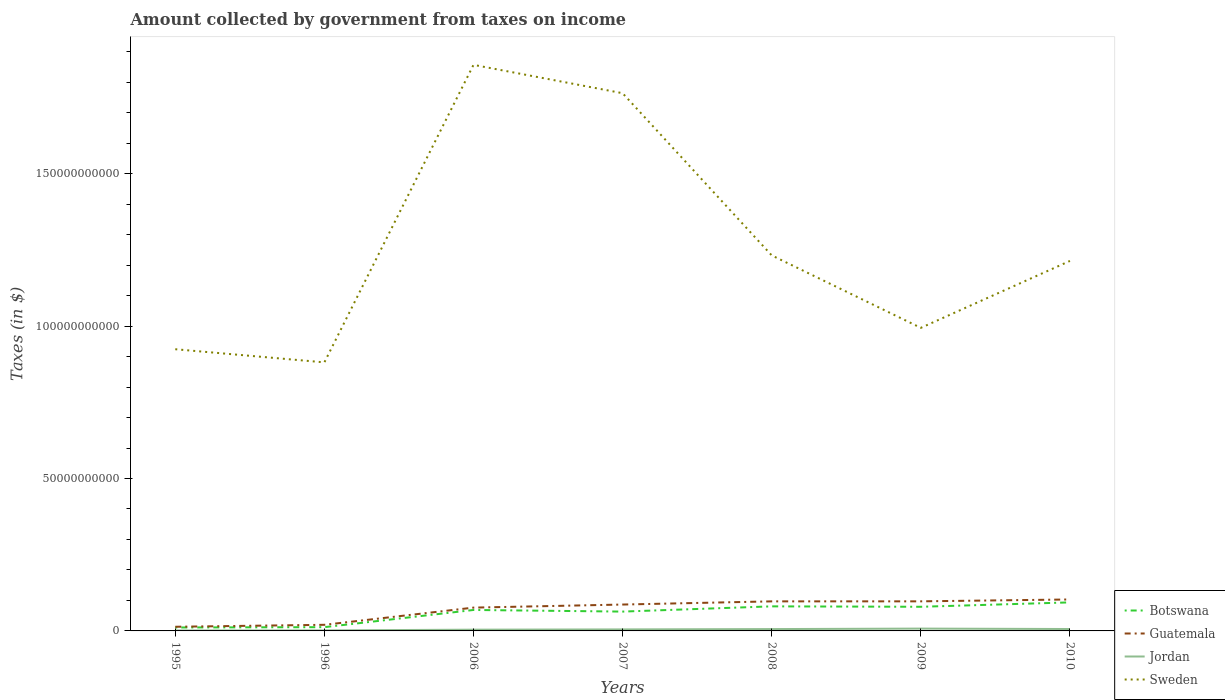How many different coloured lines are there?
Give a very brief answer. 4. Is the number of lines equal to the number of legend labels?
Your answer should be compact. Yes. Across all years, what is the maximum amount collected by government from taxes on income in Jordan?
Give a very brief answer. 1.52e+08. In which year was the amount collected by government from taxes on income in Botswana maximum?
Your response must be concise. 1995. What is the total amount collected by government from taxes on income in Jordan in the graph?
Ensure brevity in your answer.  1.40e+08. What is the difference between the highest and the second highest amount collected by government from taxes on income in Sweden?
Make the answer very short. 9.76e+1. How many lines are there?
Give a very brief answer. 4. Are the values on the major ticks of Y-axis written in scientific E-notation?
Your answer should be compact. No. Does the graph contain grids?
Your answer should be very brief. No. How many legend labels are there?
Ensure brevity in your answer.  4. What is the title of the graph?
Give a very brief answer. Amount collected by government from taxes on income. What is the label or title of the X-axis?
Give a very brief answer. Years. What is the label or title of the Y-axis?
Provide a succinct answer. Taxes (in $). What is the Taxes (in $) in Botswana in 1995?
Ensure brevity in your answer.  1.13e+09. What is the Taxes (in $) in Guatemala in 1995?
Your answer should be very brief. 1.37e+09. What is the Taxes (in $) of Jordan in 1995?
Make the answer very short. 1.52e+08. What is the Taxes (in $) of Sweden in 1995?
Offer a very short reply. 9.24e+1. What is the Taxes (in $) of Botswana in 1996?
Your response must be concise. 1.23e+09. What is the Taxes (in $) in Guatemala in 1996?
Ensure brevity in your answer.  2.00e+09. What is the Taxes (in $) of Jordan in 1996?
Provide a succinct answer. 1.73e+08. What is the Taxes (in $) of Sweden in 1996?
Your response must be concise. 8.81e+1. What is the Taxes (in $) in Botswana in 2006?
Your response must be concise. 6.88e+09. What is the Taxes (in $) of Guatemala in 2006?
Give a very brief answer. 7.65e+09. What is the Taxes (in $) of Jordan in 2006?
Keep it short and to the point. 4.11e+08. What is the Taxes (in $) in Sweden in 2006?
Keep it short and to the point. 1.86e+11. What is the Taxes (in $) of Botswana in 2007?
Ensure brevity in your answer.  6.34e+09. What is the Taxes (in $) of Guatemala in 2007?
Make the answer very short. 8.65e+09. What is the Taxes (in $) in Jordan in 2007?
Offer a very short reply. 4.95e+08. What is the Taxes (in $) of Sweden in 2007?
Your response must be concise. 1.76e+11. What is the Taxes (in $) of Botswana in 2008?
Provide a short and direct response. 8.06e+09. What is the Taxes (in $) of Guatemala in 2008?
Provide a short and direct response. 9.70e+09. What is the Taxes (in $) in Jordan in 2008?
Offer a terse response. 6.03e+08. What is the Taxes (in $) in Sweden in 2008?
Give a very brief answer. 1.23e+11. What is the Taxes (in $) in Botswana in 2009?
Keep it short and to the point. 7.92e+09. What is the Taxes (in $) in Guatemala in 2009?
Offer a terse response. 9.71e+09. What is the Taxes (in $) in Jordan in 2009?
Make the answer very short. 7.65e+08. What is the Taxes (in $) in Sweden in 2009?
Your answer should be compact. 9.94e+1. What is the Taxes (in $) in Botswana in 2010?
Provide a succinct answer. 9.36e+09. What is the Taxes (in $) of Guatemala in 2010?
Offer a terse response. 1.03e+1. What is the Taxes (in $) in Jordan in 2010?
Provide a short and direct response. 6.25e+08. What is the Taxes (in $) of Sweden in 2010?
Your answer should be compact. 1.21e+11. Across all years, what is the maximum Taxes (in $) of Botswana?
Your answer should be very brief. 9.36e+09. Across all years, what is the maximum Taxes (in $) in Guatemala?
Provide a short and direct response. 1.03e+1. Across all years, what is the maximum Taxes (in $) of Jordan?
Keep it short and to the point. 7.65e+08. Across all years, what is the maximum Taxes (in $) of Sweden?
Provide a short and direct response. 1.86e+11. Across all years, what is the minimum Taxes (in $) of Botswana?
Your answer should be compact. 1.13e+09. Across all years, what is the minimum Taxes (in $) in Guatemala?
Your response must be concise. 1.37e+09. Across all years, what is the minimum Taxes (in $) in Jordan?
Your answer should be compact. 1.52e+08. Across all years, what is the minimum Taxes (in $) in Sweden?
Offer a very short reply. 8.81e+1. What is the total Taxes (in $) in Botswana in the graph?
Your response must be concise. 4.09e+1. What is the total Taxes (in $) in Guatemala in the graph?
Provide a short and direct response. 4.94e+1. What is the total Taxes (in $) in Jordan in the graph?
Your answer should be very brief. 3.22e+09. What is the total Taxes (in $) of Sweden in the graph?
Make the answer very short. 8.87e+11. What is the difference between the Taxes (in $) of Botswana in 1995 and that in 1996?
Keep it short and to the point. -1.07e+08. What is the difference between the Taxes (in $) in Guatemala in 1995 and that in 1996?
Ensure brevity in your answer.  -6.39e+08. What is the difference between the Taxes (in $) of Jordan in 1995 and that in 1996?
Give a very brief answer. -2.06e+07. What is the difference between the Taxes (in $) in Sweden in 1995 and that in 1996?
Keep it short and to the point. 4.31e+09. What is the difference between the Taxes (in $) of Botswana in 1995 and that in 2006?
Ensure brevity in your answer.  -5.75e+09. What is the difference between the Taxes (in $) of Guatemala in 1995 and that in 2006?
Provide a short and direct response. -6.28e+09. What is the difference between the Taxes (in $) in Jordan in 1995 and that in 2006?
Your response must be concise. -2.59e+08. What is the difference between the Taxes (in $) of Sweden in 1995 and that in 2006?
Keep it short and to the point. -9.33e+1. What is the difference between the Taxes (in $) of Botswana in 1995 and that in 2007?
Your answer should be compact. -5.22e+09. What is the difference between the Taxes (in $) in Guatemala in 1995 and that in 2007?
Provide a succinct answer. -7.29e+09. What is the difference between the Taxes (in $) of Jordan in 1995 and that in 2007?
Keep it short and to the point. -3.42e+08. What is the difference between the Taxes (in $) of Sweden in 1995 and that in 2007?
Provide a short and direct response. -8.40e+1. What is the difference between the Taxes (in $) in Botswana in 1995 and that in 2008?
Offer a terse response. -6.93e+09. What is the difference between the Taxes (in $) in Guatemala in 1995 and that in 2008?
Offer a terse response. -8.33e+09. What is the difference between the Taxes (in $) in Jordan in 1995 and that in 2008?
Offer a very short reply. -4.51e+08. What is the difference between the Taxes (in $) of Sweden in 1995 and that in 2008?
Your answer should be very brief. -3.08e+1. What is the difference between the Taxes (in $) in Botswana in 1995 and that in 2009?
Ensure brevity in your answer.  -6.79e+09. What is the difference between the Taxes (in $) of Guatemala in 1995 and that in 2009?
Provide a short and direct response. -8.34e+09. What is the difference between the Taxes (in $) of Jordan in 1995 and that in 2009?
Keep it short and to the point. -6.12e+08. What is the difference between the Taxes (in $) of Sweden in 1995 and that in 2009?
Provide a succinct answer. -7.01e+09. What is the difference between the Taxes (in $) in Botswana in 1995 and that in 2010?
Ensure brevity in your answer.  -8.24e+09. What is the difference between the Taxes (in $) of Guatemala in 1995 and that in 2010?
Your answer should be compact. -8.95e+09. What is the difference between the Taxes (in $) of Jordan in 1995 and that in 2010?
Your answer should be very brief. -4.72e+08. What is the difference between the Taxes (in $) of Sweden in 1995 and that in 2010?
Provide a succinct answer. -2.90e+1. What is the difference between the Taxes (in $) of Botswana in 1996 and that in 2006?
Keep it short and to the point. -5.64e+09. What is the difference between the Taxes (in $) in Guatemala in 1996 and that in 2006?
Make the answer very short. -5.64e+09. What is the difference between the Taxes (in $) in Jordan in 1996 and that in 2006?
Offer a very short reply. -2.38e+08. What is the difference between the Taxes (in $) of Sweden in 1996 and that in 2006?
Your response must be concise. -9.76e+1. What is the difference between the Taxes (in $) of Botswana in 1996 and that in 2007?
Provide a succinct answer. -5.11e+09. What is the difference between the Taxes (in $) in Guatemala in 1996 and that in 2007?
Make the answer very short. -6.65e+09. What is the difference between the Taxes (in $) of Jordan in 1996 and that in 2007?
Offer a terse response. -3.22e+08. What is the difference between the Taxes (in $) of Sweden in 1996 and that in 2007?
Ensure brevity in your answer.  -8.83e+1. What is the difference between the Taxes (in $) of Botswana in 1996 and that in 2008?
Your response must be concise. -6.83e+09. What is the difference between the Taxes (in $) of Guatemala in 1996 and that in 2008?
Your answer should be compact. -7.69e+09. What is the difference between the Taxes (in $) of Jordan in 1996 and that in 2008?
Give a very brief answer. -4.30e+08. What is the difference between the Taxes (in $) of Sweden in 1996 and that in 2008?
Your answer should be very brief. -3.51e+1. What is the difference between the Taxes (in $) in Botswana in 1996 and that in 2009?
Keep it short and to the point. -6.69e+09. What is the difference between the Taxes (in $) in Guatemala in 1996 and that in 2009?
Offer a very short reply. -7.70e+09. What is the difference between the Taxes (in $) of Jordan in 1996 and that in 2009?
Keep it short and to the point. -5.92e+08. What is the difference between the Taxes (in $) in Sweden in 1996 and that in 2009?
Your answer should be compact. -1.13e+1. What is the difference between the Taxes (in $) in Botswana in 1996 and that in 2010?
Offer a terse response. -8.13e+09. What is the difference between the Taxes (in $) in Guatemala in 1996 and that in 2010?
Give a very brief answer. -8.32e+09. What is the difference between the Taxes (in $) of Jordan in 1996 and that in 2010?
Provide a short and direct response. -4.52e+08. What is the difference between the Taxes (in $) of Sweden in 1996 and that in 2010?
Make the answer very short. -3.33e+1. What is the difference between the Taxes (in $) of Botswana in 2006 and that in 2007?
Your answer should be compact. 5.33e+08. What is the difference between the Taxes (in $) in Guatemala in 2006 and that in 2007?
Offer a very short reply. -1.01e+09. What is the difference between the Taxes (in $) of Jordan in 2006 and that in 2007?
Provide a succinct answer. -8.35e+07. What is the difference between the Taxes (in $) in Sweden in 2006 and that in 2007?
Make the answer very short. 9.30e+09. What is the difference between the Taxes (in $) in Botswana in 2006 and that in 2008?
Offer a very short reply. -1.18e+09. What is the difference between the Taxes (in $) of Guatemala in 2006 and that in 2008?
Offer a terse response. -2.05e+09. What is the difference between the Taxes (in $) of Jordan in 2006 and that in 2008?
Your answer should be compact. -1.92e+08. What is the difference between the Taxes (in $) of Sweden in 2006 and that in 2008?
Keep it short and to the point. 6.25e+1. What is the difference between the Taxes (in $) in Botswana in 2006 and that in 2009?
Your response must be concise. -1.05e+09. What is the difference between the Taxes (in $) in Guatemala in 2006 and that in 2009?
Ensure brevity in your answer.  -2.06e+09. What is the difference between the Taxes (in $) of Jordan in 2006 and that in 2009?
Ensure brevity in your answer.  -3.53e+08. What is the difference between the Taxes (in $) in Sweden in 2006 and that in 2009?
Ensure brevity in your answer.  8.63e+1. What is the difference between the Taxes (in $) of Botswana in 2006 and that in 2010?
Offer a very short reply. -2.49e+09. What is the difference between the Taxes (in $) in Guatemala in 2006 and that in 2010?
Offer a very short reply. -2.67e+09. What is the difference between the Taxes (in $) of Jordan in 2006 and that in 2010?
Provide a short and direct response. -2.13e+08. What is the difference between the Taxes (in $) in Sweden in 2006 and that in 2010?
Offer a very short reply. 6.43e+1. What is the difference between the Taxes (in $) of Botswana in 2007 and that in 2008?
Your answer should be compact. -1.72e+09. What is the difference between the Taxes (in $) in Guatemala in 2007 and that in 2008?
Give a very brief answer. -1.04e+09. What is the difference between the Taxes (in $) of Jordan in 2007 and that in 2008?
Make the answer very short. -1.08e+08. What is the difference between the Taxes (in $) of Sweden in 2007 and that in 2008?
Keep it short and to the point. 5.32e+1. What is the difference between the Taxes (in $) of Botswana in 2007 and that in 2009?
Offer a terse response. -1.58e+09. What is the difference between the Taxes (in $) in Guatemala in 2007 and that in 2009?
Offer a very short reply. -1.05e+09. What is the difference between the Taxes (in $) in Jordan in 2007 and that in 2009?
Your answer should be compact. -2.70e+08. What is the difference between the Taxes (in $) of Sweden in 2007 and that in 2009?
Make the answer very short. 7.70e+1. What is the difference between the Taxes (in $) in Botswana in 2007 and that in 2010?
Ensure brevity in your answer.  -3.02e+09. What is the difference between the Taxes (in $) of Guatemala in 2007 and that in 2010?
Provide a short and direct response. -1.67e+09. What is the difference between the Taxes (in $) of Jordan in 2007 and that in 2010?
Offer a very short reply. -1.30e+08. What is the difference between the Taxes (in $) of Sweden in 2007 and that in 2010?
Provide a short and direct response. 5.50e+1. What is the difference between the Taxes (in $) of Botswana in 2008 and that in 2009?
Provide a short and direct response. 1.40e+08. What is the difference between the Taxes (in $) of Guatemala in 2008 and that in 2009?
Offer a terse response. -7.40e+06. What is the difference between the Taxes (in $) of Jordan in 2008 and that in 2009?
Give a very brief answer. -1.61e+08. What is the difference between the Taxes (in $) of Sweden in 2008 and that in 2009?
Your answer should be compact. 2.38e+1. What is the difference between the Taxes (in $) in Botswana in 2008 and that in 2010?
Your response must be concise. -1.30e+09. What is the difference between the Taxes (in $) in Guatemala in 2008 and that in 2010?
Your answer should be compact. -6.21e+08. What is the difference between the Taxes (in $) in Jordan in 2008 and that in 2010?
Ensure brevity in your answer.  -2.12e+07. What is the difference between the Taxes (in $) in Sweden in 2008 and that in 2010?
Make the answer very short. 1.82e+09. What is the difference between the Taxes (in $) in Botswana in 2009 and that in 2010?
Keep it short and to the point. -1.44e+09. What is the difference between the Taxes (in $) in Guatemala in 2009 and that in 2010?
Offer a terse response. -6.13e+08. What is the difference between the Taxes (in $) of Jordan in 2009 and that in 2010?
Provide a succinct answer. 1.40e+08. What is the difference between the Taxes (in $) of Sweden in 2009 and that in 2010?
Ensure brevity in your answer.  -2.20e+1. What is the difference between the Taxes (in $) in Botswana in 1995 and the Taxes (in $) in Guatemala in 1996?
Give a very brief answer. -8.77e+08. What is the difference between the Taxes (in $) in Botswana in 1995 and the Taxes (in $) in Jordan in 1996?
Provide a succinct answer. 9.54e+08. What is the difference between the Taxes (in $) of Botswana in 1995 and the Taxes (in $) of Sweden in 1996?
Your answer should be compact. -8.70e+1. What is the difference between the Taxes (in $) in Guatemala in 1995 and the Taxes (in $) in Jordan in 1996?
Provide a succinct answer. 1.19e+09. What is the difference between the Taxes (in $) in Guatemala in 1995 and the Taxes (in $) in Sweden in 1996?
Ensure brevity in your answer.  -8.67e+1. What is the difference between the Taxes (in $) in Jordan in 1995 and the Taxes (in $) in Sweden in 1996?
Ensure brevity in your answer.  -8.80e+1. What is the difference between the Taxes (in $) in Botswana in 1995 and the Taxes (in $) in Guatemala in 2006?
Offer a very short reply. -6.52e+09. What is the difference between the Taxes (in $) in Botswana in 1995 and the Taxes (in $) in Jordan in 2006?
Give a very brief answer. 7.16e+08. What is the difference between the Taxes (in $) of Botswana in 1995 and the Taxes (in $) of Sweden in 2006?
Keep it short and to the point. -1.85e+11. What is the difference between the Taxes (in $) in Guatemala in 1995 and the Taxes (in $) in Jordan in 2006?
Your answer should be very brief. 9.54e+08. What is the difference between the Taxes (in $) of Guatemala in 1995 and the Taxes (in $) of Sweden in 2006?
Your answer should be compact. -1.84e+11. What is the difference between the Taxes (in $) in Jordan in 1995 and the Taxes (in $) in Sweden in 2006?
Your answer should be very brief. -1.86e+11. What is the difference between the Taxes (in $) in Botswana in 1995 and the Taxes (in $) in Guatemala in 2007?
Your answer should be compact. -7.53e+09. What is the difference between the Taxes (in $) in Botswana in 1995 and the Taxes (in $) in Jordan in 2007?
Offer a terse response. 6.32e+08. What is the difference between the Taxes (in $) of Botswana in 1995 and the Taxes (in $) of Sweden in 2007?
Make the answer very short. -1.75e+11. What is the difference between the Taxes (in $) in Guatemala in 1995 and the Taxes (in $) in Jordan in 2007?
Your response must be concise. 8.70e+08. What is the difference between the Taxes (in $) in Guatemala in 1995 and the Taxes (in $) in Sweden in 2007?
Offer a very short reply. -1.75e+11. What is the difference between the Taxes (in $) of Jordan in 1995 and the Taxes (in $) of Sweden in 2007?
Provide a short and direct response. -1.76e+11. What is the difference between the Taxes (in $) in Botswana in 1995 and the Taxes (in $) in Guatemala in 2008?
Keep it short and to the point. -8.57e+09. What is the difference between the Taxes (in $) of Botswana in 1995 and the Taxes (in $) of Jordan in 2008?
Your answer should be compact. 5.24e+08. What is the difference between the Taxes (in $) of Botswana in 1995 and the Taxes (in $) of Sweden in 2008?
Provide a short and direct response. -1.22e+11. What is the difference between the Taxes (in $) of Guatemala in 1995 and the Taxes (in $) of Jordan in 2008?
Keep it short and to the point. 7.62e+08. What is the difference between the Taxes (in $) in Guatemala in 1995 and the Taxes (in $) in Sweden in 2008?
Keep it short and to the point. -1.22e+11. What is the difference between the Taxes (in $) of Jordan in 1995 and the Taxes (in $) of Sweden in 2008?
Offer a very short reply. -1.23e+11. What is the difference between the Taxes (in $) of Botswana in 1995 and the Taxes (in $) of Guatemala in 2009?
Ensure brevity in your answer.  -8.58e+09. What is the difference between the Taxes (in $) of Botswana in 1995 and the Taxes (in $) of Jordan in 2009?
Provide a short and direct response. 3.62e+08. What is the difference between the Taxes (in $) in Botswana in 1995 and the Taxes (in $) in Sweden in 2009?
Ensure brevity in your answer.  -9.83e+1. What is the difference between the Taxes (in $) in Guatemala in 1995 and the Taxes (in $) in Jordan in 2009?
Give a very brief answer. 6.00e+08. What is the difference between the Taxes (in $) in Guatemala in 1995 and the Taxes (in $) in Sweden in 2009?
Ensure brevity in your answer.  -9.81e+1. What is the difference between the Taxes (in $) of Jordan in 1995 and the Taxes (in $) of Sweden in 2009?
Your answer should be very brief. -9.93e+1. What is the difference between the Taxes (in $) of Botswana in 1995 and the Taxes (in $) of Guatemala in 2010?
Your answer should be very brief. -9.19e+09. What is the difference between the Taxes (in $) of Botswana in 1995 and the Taxes (in $) of Jordan in 2010?
Your response must be concise. 5.02e+08. What is the difference between the Taxes (in $) in Botswana in 1995 and the Taxes (in $) in Sweden in 2010?
Ensure brevity in your answer.  -1.20e+11. What is the difference between the Taxes (in $) in Guatemala in 1995 and the Taxes (in $) in Jordan in 2010?
Provide a succinct answer. 7.41e+08. What is the difference between the Taxes (in $) of Guatemala in 1995 and the Taxes (in $) of Sweden in 2010?
Provide a succinct answer. -1.20e+11. What is the difference between the Taxes (in $) of Jordan in 1995 and the Taxes (in $) of Sweden in 2010?
Your response must be concise. -1.21e+11. What is the difference between the Taxes (in $) in Botswana in 1996 and the Taxes (in $) in Guatemala in 2006?
Offer a terse response. -6.41e+09. What is the difference between the Taxes (in $) of Botswana in 1996 and the Taxes (in $) of Jordan in 2006?
Give a very brief answer. 8.22e+08. What is the difference between the Taxes (in $) of Botswana in 1996 and the Taxes (in $) of Sweden in 2006?
Give a very brief answer. -1.84e+11. What is the difference between the Taxes (in $) in Guatemala in 1996 and the Taxes (in $) in Jordan in 2006?
Your answer should be compact. 1.59e+09. What is the difference between the Taxes (in $) in Guatemala in 1996 and the Taxes (in $) in Sweden in 2006?
Offer a very short reply. -1.84e+11. What is the difference between the Taxes (in $) of Jordan in 1996 and the Taxes (in $) of Sweden in 2006?
Offer a terse response. -1.86e+11. What is the difference between the Taxes (in $) in Botswana in 1996 and the Taxes (in $) in Guatemala in 2007?
Your response must be concise. -7.42e+09. What is the difference between the Taxes (in $) of Botswana in 1996 and the Taxes (in $) of Jordan in 2007?
Make the answer very short. 7.39e+08. What is the difference between the Taxes (in $) of Botswana in 1996 and the Taxes (in $) of Sweden in 2007?
Your answer should be compact. -1.75e+11. What is the difference between the Taxes (in $) of Guatemala in 1996 and the Taxes (in $) of Jordan in 2007?
Your answer should be very brief. 1.51e+09. What is the difference between the Taxes (in $) in Guatemala in 1996 and the Taxes (in $) in Sweden in 2007?
Keep it short and to the point. -1.74e+11. What is the difference between the Taxes (in $) in Jordan in 1996 and the Taxes (in $) in Sweden in 2007?
Offer a very short reply. -1.76e+11. What is the difference between the Taxes (in $) in Botswana in 1996 and the Taxes (in $) in Guatemala in 2008?
Offer a very short reply. -8.46e+09. What is the difference between the Taxes (in $) in Botswana in 1996 and the Taxes (in $) in Jordan in 2008?
Offer a terse response. 6.30e+08. What is the difference between the Taxes (in $) of Botswana in 1996 and the Taxes (in $) of Sweden in 2008?
Provide a short and direct response. -1.22e+11. What is the difference between the Taxes (in $) of Guatemala in 1996 and the Taxes (in $) of Jordan in 2008?
Offer a very short reply. 1.40e+09. What is the difference between the Taxes (in $) in Guatemala in 1996 and the Taxes (in $) in Sweden in 2008?
Provide a succinct answer. -1.21e+11. What is the difference between the Taxes (in $) of Jordan in 1996 and the Taxes (in $) of Sweden in 2008?
Your response must be concise. -1.23e+11. What is the difference between the Taxes (in $) in Botswana in 1996 and the Taxes (in $) in Guatemala in 2009?
Provide a short and direct response. -8.47e+09. What is the difference between the Taxes (in $) in Botswana in 1996 and the Taxes (in $) in Jordan in 2009?
Provide a short and direct response. 4.69e+08. What is the difference between the Taxes (in $) of Botswana in 1996 and the Taxes (in $) of Sweden in 2009?
Give a very brief answer. -9.82e+1. What is the difference between the Taxes (in $) of Guatemala in 1996 and the Taxes (in $) of Jordan in 2009?
Give a very brief answer. 1.24e+09. What is the difference between the Taxes (in $) of Guatemala in 1996 and the Taxes (in $) of Sweden in 2009?
Your response must be concise. -9.74e+1. What is the difference between the Taxes (in $) of Jordan in 1996 and the Taxes (in $) of Sweden in 2009?
Make the answer very short. -9.93e+1. What is the difference between the Taxes (in $) in Botswana in 1996 and the Taxes (in $) in Guatemala in 2010?
Offer a very short reply. -9.09e+09. What is the difference between the Taxes (in $) of Botswana in 1996 and the Taxes (in $) of Jordan in 2010?
Keep it short and to the point. 6.09e+08. What is the difference between the Taxes (in $) of Botswana in 1996 and the Taxes (in $) of Sweden in 2010?
Provide a short and direct response. -1.20e+11. What is the difference between the Taxes (in $) in Guatemala in 1996 and the Taxes (in $) in Jordan in 2010?
Ensure brevity in your answer.  1.38e+09. What is the difference between the Taxes (in $) of Guatemala in 1996 and the Taxes (in $) of Sweden in 2010?
Offer a very short reply. -1.19e+11. What is the difference between the Taxes (in $) of Jordan in 1996 and the Taxes (in $) of Sweden in 2010?
Your answer should be very brief. -1.21e+11. What is the difference between the Taxes (in $) in Botswana in 2006 and the Taxes (in $) in Guatemala in 2007?
Offer a terse response. -1.78e+09. What is the difference between the Taxes (in $) of Botswana in 2006 and the Taxes (in $) of Jordan in 2007?
Your response must be concise. 6.38e+09. What is the difference between the Taxes (in $) in Botswana in 2006 and the Taxes (in $) in Sweden in 2007?
Keep it short and to the point. -1.70e+11. What is the difference between the Taxes (in $) of Guatemala in 2006 and the Taxes (in $) of Jordan in 2007?
Your response must be concise. 7.15e+09. What is the difference between the Taxes (in $) of Guatemala in 2006 and the Taxes (in $) of Sweden in 2007?
Your answer should be very brief. -1.69e+11. What is the difference between the Taxes (in $) of Jordan in 2006 and the Taxes (in $) of Sweden in 2007?
Your answer should be compact. -1.76e+11. What is the difference between the Taxes (in $) in Botswana in 2006 and the Taxes (in $) in Guatemala in 2008?
Your answer should be compact. -2.82e+09. What is the difference between the Taxes (in $) of Botswana in 2006 and the Taxes (in $) of Jordan in 2008?
Your answer should be very brief. 6.27e+09. What is the difference between the Taxes (in $) of Botswana in 2006 and the Taxes (in $) of Sweden in 2008?
Your response must be concise. -1.16e+11. What is the difference between the Taxes (in $) in Guatemala in 2006 and the Taxes (in $) in Jordan in 2008?
Provide a short and direct response. 7.04e+09. What is the difference between the Taxes (in $) in Guatemala in 2006 and the Taxes (in $) in Sweden in 2008?
Your answer should be very brief. -1.16e+11. What is the difference between the Taxes (in $) of Jordan in 2006 and the Taxes (in $) of Sweden in 2008?
Offer a very short reply. -1.23e+11. What is the difference between the Taxes (in $) in Botswana in 2006 and the Taxes (in $) in Guatemala in 2009?
Offer a terse response. -2.83e+09. What is the difference between the Taxes (in $) in Botswana in 2006 and the Taxes (in $) in Jordan in 2009?
Your answer should be very brief. 6.11e+09. What is the difference between the Taxes (in $) in Botswana in 2006 and the Taxes (in $) in Sweden in 2009?
Provide a short and direct response. -9.26e+1. What is the difference between the Taxes (in $) of Guatemala in 2006 and the Taxes (in $) of Jordan in 2009?
Provide a succinct answer. 6.88e+09. What is the difference between the Taxes (in $) in Guatemala in 2006 and the Taxes (in $) in Sweden in 2009?
Your answer should be compact. -9.18e+1. What is the difference between the Taxes (in $) in Jordan in 2006 and the Taxes (in $) in Sweden in 2009?
Your answer should be compact. -9.90e+1. What is the difference between the Taxes (in $) of Botswana in 2006 and the Taxes (in $) of Guatemala in 2010?
Ensure brevity in your answer.  -3.44e+09. What is the difference between the Taxes (in $) of Botswana in 2006 and the Taxes (in $) of Jordan in 2010?
Provide a short and direct response. 6.25e+09. What is the difference between the Taxes (in $) of Botswana in 2006 and the Taxes (in $) of Sweden in 2010?
Offer a very short reply. -1.15e+11. What is the difference between the Taxes (in $) in Guatemala in 2006 and the Taxes (in $) in Jordan in 2010?
Provide a succinct answer. 7.02e+09. What is the difference between the Taxes (in $) in Guatemala in 2006 and the Taxes (in $) in Sweden in 2010?
Make the answer very short. -1.14e+11. What is the difference between the Taxes (in $) of Jordan in 2006 and the Taxes (in $) of Sweden in 2010?
Offer a terse response. -1.21e+11. What is the difference between the Taxes (in $) in Botswana in 2007 and the Taxes (in $) in Guatemala in 2008?
Your answer should be compact. -3.36e+09. What is the difference between the Taxes (in $) of Botswana in 2007 and the Taxes (in $) of Jordan in 2008?
Make the answer very short. 5.74e+09. What is the difference between the Taxes (in $) in Botswana in 2007 and the Taxes (in $) in Sweden in 2008?
Offer a terse response. -1.17e+11. What is the difference between the Taxes (in $) in Guatemala in 2007 and the Taxes (in $) in Jordan in 2008?
Offer a terse response. 8.05e+09. What is the difference between the Taxes (in $) in Guatemala in 2007 and the Taxes (in $) in Sweden in 2008?
Ensure brevity in your answer.  -1.15e+11. What is the difference between the Taxes (in $) in Jordan in 2007 and the Taxes (in $) in Sweden in 2008?
Your answer should be compact. -1.23e+11. What is the difference between the Taxes (in $) in Botswana in 2007 and the Taxes (in $) in Guatemala in 2009?
Provide a short and direct response. -3.36e+09. What is the difference between the Taxes (in $) of Botswana in 2007 and the Taxes (in $) of Jordan in 2009?
Keep it short and to the point. 5.58e+09. What is the difference between the Taxes (in $) of Botswana in 2007 and the Taxes (in $) of Sweden in 2009?
Offer a terse response. -9.31e+1. What is the difference between the Taxes (in $) in Guatemala in 2007 and the Taxes (in $) in Jordan in 2009?
Ensure brevity in your answer.  7.89e+09. What is the difference between the Taxes (in $) of Guatemala in 2007 and the Taxes (in $) of Sweden in 2009?
Your answer should be very brief. -9.08e+1. What is the difference between the Taxes (in $) in Jordan in 2007 and the Taxes (in $) in Sweden in 2009?
Make the answer very short. -9.89e+1. What is the difference between the Taxes (in $) in Botswana in 2007 and the Taxes (in $) in Guatemala in 2010?
Your answer should be very brief. -3.98e+09. What is the difference between the Taxes (in $) in Botswana in 2007 and the Taxes (in $) in Jordan in 2010?
Offer a terse response. 5.72e+09. What is the difference between the Taxes (in $) in Botswana in 2007 and the Taxes (in $) in Sweden in 2010?
Keep it short and to the point. -1.15e+11. What is the difference between the Taxes (in $) in Guatemala in 2007 and the Taxes (in $) in Jordan in 2010?
Provide a succinct answer. 8.03e+09. What is the difference between the Taxes (in $) in Guatemala in 2007 and the Taxes (in $) in Sweden in 2010?
Offer a very short reply. -1.13e+11. What is the difference between the Taxes (in $) of Jordan in 2007 and the Taxes (in $) of Sweden in 2010?
Provide a succinct answer. -1.21e+11. What is the difference between the Taxes (in $) in Botswana in 2008 and the Taxes (in $) in Guatemala in 2009?
Make the answer very short. -1.65e+09. What is the difference between the Taxes (in $) in Botswana in 2008 and the Taxes (in $) in Jordan in 2009?
Ensure brevity in your answer.  7.30e+09. What is the difference between the Taxes (in $) in Botswana in 2008 and the Taxes (in $) in Sweden in 2009?
Your answer should be compact. -9.14e+1. What is the difference between the Taxes (in $) in Guatemala in 2008 and the Taxes (in $) in Jordan in 2009?
Your response must be concise. 8.93e+09. What is the difference between the Taxes (in $) in Guatemala in 2008 and the Taxes (in $) in Sweden in 2009?
Offer a very short reply. -8.97e+1. What is the difference between the Taxes (in $) of Jordan in 2008 and the Taxes (in $) of Sweden in 2009?
Provide a succinct answer. -9.88e+1. What is the difference between the Taxes (in $) in Botswana in 2008 and the Taxes (in $) in Guatemala in 2010?
Your response must be concise. -2.26e+09. What is the difference between the Taxes (in $) in Botswana in 2008 and the Taxes (in $) in Jordan in 2010?
Offer a very short reply. 7.44e+09. What is the difference between the Taxes (in $) of Botswana in 2008 and the Taxes (in $) of Sweden in 2010?
Your response must be concise. -1.13e+11. What is the difference between the Taxes (in $) in Guatemala in 2008 and the Taxes (in $) in Jordan in 2010?
Offer a very short reply. 9.07e+09. What is the difference between the Taxes (in $) of Guatemala in 2008 and the Taxes (in $) of Sweden in 2010?
Your answer should be compact. -1.12e+11. What is the difference between the Taxes (in $) in Jordan in 2008 and the Taxes (in $) in Sweden in 2010?
Make the answer very short. -1.21e+11. What is the difference between the Taxes (in $) of Botswana in 2009 and the Taxes (in $) of Guatemala in 2010?
Offer a very short reply. -2.40e+09. What is the difference between the Taxes (in $) in Botswana in 2009 and the Taxes (in $) in Jordan in 2010?
Ensure brevity in your answer.  7.30e+09. What is the difference between the Taxes (in $) of Botswana in 2009 and the Taxes (in $) of Sweden in 2010?
Offer a terse response. -1.13e+11. What is the difference between the Taxes (in $) in Guatemala in 2009 and the Taxes (in $) in Jordan in 2010?
Your answer should be very brief. 9.08e+09. What is the difference between the Taxes (in $) of Guatemala in 2009 and the Taxes (in $) of Sweden in 2010?
Your answer should be compact. -1.12e+11. What is the difference between the Taxes (in $) in Jordan in 2009 and the Taxes (in $) in Sweden in 2010?
Give a very brief answer. -1.21e+11. What is the average Taxes (in $) of Botswana per year?
Provide a short and direct response. 5.85e+09. What is the average Taxes (in $) of Guatemala per year?
Provide a succinct answer. 7.06e+09. What is the average Taxes (in $) in Jordan per year?
Ensure brevity in your answer.  4.61e+08. What is the average Taxes (in $) of Sweden per year?
Your answer should be compact. 1.27e+11. In the year 1995, what is the difference between the Taxes (in $) of Botswana and Taxes (in $) of Guatemala?
Provide a short and direct response. -2.38e+08. In the year 1995, what is the difference between the Taxes (in $) in Botswana and Taxes (in $) in Jordan?
Your answer should be compact. 9.75e+08. In the year 1995, what is the difference between the Taxes (in $) of Botswana and Taxes (in $) of Sweden?
Provide a succinct answer. -9.13e+1. In the year 1995, what is the difference between the Taxes (in $) of Guatemala and Taxes (in $) of Jordan?
Your answer should be very brief. 1.21e+09. In the year 1995, what is the difference between the Taxes (in $) of Guatemala and Taxes (in $) of Sweden?
Your response must be concise. -9.11e+1. In the year 1995, what is the difference between the Taxes (in $) in Jordan and Taxes (in $) in Sweden?
Provide a short and direct response. -9.23e+1. In the year 1996, what is the difference between the Taxes (in $) of Botswana and Taxes (in $) of Guatemala?
Offer a very short reply. -7.70e+08. In the year 1996, what is the difference between the Taxes (in $) of Botswana and Taxes (in $) of Jordan?
Make the answer very short. 1.06e+09. In the year 1996, what is the difference between the Taxes (in $) of Botswana and Taxes (in $) of Sweden?
Your response must be concise. -8.69e+1. In the year 1996, what is the difference between the Taxes (in $) in Guatemala and Taxes (in $) in Jordan?
Your answer should be compact. 1.83e+09. In the year 1996, what is the difference between the Taxes (in $) in Guatemala and Taxes (in $) in Sweden?
Your response must be concise. -8.61e+1. In the year 1996, what is the difference between the Taxes (in $) of Jordan and Taxes (in $) of Sweden?
Provide a succinct answer. -8.79e+1. In the year 2006, what is the difference between the Taxes (in $) in Botswana and Taxes (in $) in Guatemala?
Provide a short and direct response. -7.72e+08. In the year 2006, what is the difference between the Taxes (in $) in Botswana and Taxes (in $) in Jordan?
Keep it short and to the point. 6.46e+09. In the year 2006, what is the difference between the Taxes (in $) of Botswana and Taxes (in $) of Sweden?
Make the answer very short. -1.79e+11. In the year 2006, what is the difference between the Taxes (in $) in Guatemala and Taxes (in $) in Jordan?
Make the answer very short. 7.24e+09. In the year 2006, what is the difference between the Taxes (in $) of Guatemala and Taxes (in $) of Sweden?
Keep it short and to the point. -1.78e+11. In the year 2006, what is the difference between the Taxes (in $) in Jordan and Taxes (in $) in Sweden?
Provide a succinct answer. -1.85e+11. In the year 2007, what is the difference between the Taxes (in $) in Botswana and Taxes (in $) in Guatemala?
Offer a very short reply. -2.31e+09. In the year 2007, what is the difference between the Taxes (in $) in Botswana and Taxes (in $) in Jordan?
Your answer should be compact. 5.85e+09. In the year 2007, what is the difference between the Taxes (in $) of Botswana and Taxes (in $) of Sweden?
Your response must be concise. -1.70e+11. In the year 2007, what is the difference between the Taxes (in $) of Guatemala and Taxes (in $) of Jordan?
Provide a succinct answer. 8.16e+09. In the year 2007, what is the difference between the Taxes (in $) in Guatemala and Taxes (in $) in Sweden?
Give a very brief answer. -1.68e+11. In the year 2007, what is the difference between the Taxes (in $) of Jordan and Taxes (in $) of Sweden?
Offer a terse response. -1.76e+11. In the year 2008, what is the difference between the Taxes (in $) in Botswana and Taxes (in $) in Guatemala?
Your answer should be compact. -1.64e+09. In the year 2008, what is the difference between the Taxes (in $) of Botswana and Taxes (in $) of Jordan?
Ensure brevity in your answer.  7.46e+09. In the year 2008, what is the difference between the Taxes (in $) of Botswana and Taxes (in $) of Sweden?
Ensure brevity in your answer.  -1.15e+11. In the year 2008, what is the difference between the Taxes (in $) of Guatemala and Taxes (in $) of Jordan?
Make the answer very short. 9.10e+09. In the year 2008, what is the difference between the Taxes (in $) in Guatemala and Taxes (in $) in Sweden?
Your answer should be very brief. -1.14e+11. In the year 2008, what is the difference between the Taxes (in $) of Jordan and Taxes (in $) of Sweden?
Offer a terse response. -1.23e+11. In the year 2009, what is the difference between the Taxes (in $) of Botswana and Taxes (in $) of Guatemala?
Your answer should be very brief. -1.79e+09. In the year 2009, what is the difference between the Taxes (in $) in Botswana and Taxes (in $) in Jordan?
Make the answer very short. 7.16e+09. In the year 2009, what is the difference between the Taxes (in $) in Botswana and Taxes (in $) in Sweden?
Your answer should be very brief. -9.15e+1. In the year 2009, what is the difference between the Taxes (in $) of Guatemala and Taxes (in $) of Jordan?
Your answer should be compact. 8.94e+09. In the year 2009, what is the difference between the Taxes (in $) in Guatemala and Taxes (in $) in Sweden?
Ensure brevity in your answer.  -8.97e+1. In the year 2009, what is the difference between the Taxes (in $) of Jordan and Taxes (in $) of Sweden?
Provide a short and direct response. -9.87e+1. In the year 2010, what is the difference between the Taxes (in $) in Botswana and Taxes (in $) in Guatemala?
Your answer should be very brief. -9.57e+08. In the year 2010, what is the difference between the Taxes (in $) of Botswana and Taxes (in $) of Jordan?
Keep it short and to the point. 8.74e+09. In the year 2010, what is the difference between the Taxes (in $) in Botswana and Taxes (in $) in Sweden?
Provide a short and direct response. -1.12e+11. In the year 2010, what is the difference between the Taxes (in $) in Guatemala and Taxes (in $) in Jordan?
Keep it short and to the point. 9.69e+09. In the year 2010, what is the difference between the Taxes (in $) in Guatemala and Taxes (in $) in Sweden?
Keep it short and to the point. -1.11e+11. In the year 2010, what is the difference between the Taxes (in $) in Jordan and Taxes (in $) in Sweden?
Offer a terse response. -1.21e+11. What is the ratio of the Taxes (in $) of Botswana in 1995 to that in 1996?
Provide a succinct answer. 0.91. What is the ratio of the Taxes (in $) in Guatemala in 1995 to that in 1996?
Your answer should be very brief. 0.68. What is the ratio of the Taxes (in $) in Jordan in 1995 to that in 1996?
Provide a succinct answer. 0.88. What is the ratio of the Taxes (in $) in Sweden in 1995 to that in 1996?
Ensure brevity in your answer.  1.05. What is the ratio of the Taxes (in $) in Botswana in 1995 to that in 2006?
Your response must be concise. 0.16. What is the ratio of the Taxes (in $) of Guatemala in 1995 to that in 2006?
Provide a succinct answer. 0.18. What is the ratio of the Taxes (in $) in Jordan in 1995 to that in 2006?
Ensure brevity in your answer.  0.37. What is the ratio of the Taxes (in $) of Sweden in 1995 to that in 2006?
Make the answer very short. 0.5. What is the ratio of the Taxes (in $) in Botswana in 1995 to that in 2007?
Give a very brief answer. 0.18. What is the ratio of the Taxes (in $) in Guatemala in 1995 to that in 2007?
Your answer should be compact. 0.16. What is the ratio of the Taxes (in $) of Jordan in 1995 to that in 2007?
Keep it short and to the point. 0.31. What is the ratio of the Taxes (in $) of Sweden in 1995 to that in 2007?
Your response must be concise. 0.52. What is the ratio of the Taxes (in $) of Botswana in 1995 to that in 2008?
Give a very brief answer. 0.14. What is the ratio of the Taxes (in $) in Guatemala in 1995 to that in 2008?
Offer a terse response. 0.14. What is the ratio of the Taxes (in $) in Jordan in 1995 to that in 2008?
Offer a terse response. 0.25. What is the ratio of the Taxes (in $) in Sweden in 1995 to that in 2008?
Provide a succinct answer. 0.75. What is the ratio of the Taxes (in $) of Botswana in 1995 to that in 2009?
Offer a very short reply. 0.14. What is the ratio of the Taxes (in $) of Guatemala in 1995 to that in 2009?
Your answer should be very brief. 0.14. What is the ratio of the Taxes (in $) in Jordan in 1995 to that in 2009?
Make the answer very short. 0.2. What is the ratio of the Taxes (in $) in Sweden in 1995 to that in 2009?
Give a very brief answer. 0.93. What is the ratio of the Taxes (in $) of Botswana in 1995 to that in 2010?
Make the answer very short. 0.12. What is the ratio of the Taxes (in $) in Guatemala in 1995 to that in 2010?
Ensure brevity in your answer.  0.13. What is the ratio of the Taxes (in $) in Jordan in 1995 to that in 2010?
Offer a very short reply. 0.24. What is the ratio of the Taxes (in $) of Sweden in 1995 to that in 2010?
Your answer should be compact. 0.76. What is the ratio of the Taxes (in $) in Botswana in 1996 to that in 2006?
Offer a very short reply. 0.18. What is the ratio of the Taxes (in $) in Guatemala in 1996 to that in 2006?
Provide a short and direct response. 0.26. What is the ratio of the Taxes (in $) of Jordan in 1996 to that in 2006?
Offer a terse response. 0.42. What is the ratio of the Taxes (in $) in Sweden in 1996 to that in 2006?
Your answer should be very brief. 0.47. What is the ratio of the Taxes (in $) of Botswana in 1996 to that in 2007?
Make the answer very short. 0.19. What is the ratio of the Taxes (in $) of Guatemala in 1996 to that in 2007?
Your answer should be compact. 0.23. What is the ratio of the Taxes (in $) of Jordan in 1996 to that in 2007?
Offer a very short reply. 0.35. What is the ratio of the Taxes (in $) in Sweden in 1996 to that in 2007?
Offer a very short reply. 0.5. What is the ratio of the Taxes (in $) of Botswana in 1996 to that in 2008?
Your answer should be compact. 0.15. What is the ratio of the Taxes (in $) in Guatemala in 1996 to that in 2008?
Make the answer very short. 0.21. What is the ratio of the Taxes (in $) of Jordan in 1996 to that in 2008?
Make the answer very short. 0.29. What is the ratio of the Taxes (in $) of Sweden in 1996 to that in 2008?
Make the answer very short. 0.72. What is the ratio of the Taxes (in $) of Botswana in 1996 to that in 2009?
Ensure brevity in your answer.  0.16. What is the ratio of the Taxes (in $) in Guatemala in 1996 to that in 2009?
Your answer should be compact. 0.21. What is the ratio of the Taxes (in $) in Jordan in 1996 to that in 2009?
Provide a succinct answer. 0.23. What is the ratio of the Taxes (in $) in Sweden in 1996 to that in 2009?
Keep it short and to the point. 0.89. What is the ratio of the Taxes (in $) in Botswana in 1996 to that in 2010?
Make the answer very short. 0.13. What is the ratio of the Taxes (in $) in Guatemala in 1996 to that in 2010?
Provide a succinct answer. 0.19. What is the ratio of the Taxes (in $) in Jordan in 1996 to that in 2010?
Make the answer very short. 0.28. What is the ratio of the Taxes (in $) of Sweden in 1996 to that in 2010?
Ensure brevity in your answer.  0.73. What is the ratio of the Taxes (in $) of Botswana in 2006 to that in 2007?
Make the answer very short. 1.08. What is the ratio of the Taxes (in $) in Guatemala in 2006 to that in 2007?
Your response must be concise. 0.88. What is the ratio of the Taxes (in $) in Jordan in 2006 to that in 2007?
Provide a succinct answer. 0.83. What is the ratio of the Taxes (in $) of Sweden in 2006 to that in 2007?
Your answer should be compact. 1.05. What is the ratio of the Taxes (in $) of Botswana in 2006 to that in 2008?
Provide a succinct answer. 0.85. What is the ratio of the Taxes (in $) in Guatemala in 2006 to that in 2008?
Give a very brief answer. 0.79. What is the ratio of the Taxes (in $) of Jordan in 2006 to that in 2008?
Ensure brevity in your answer.  0.68. What is the ratio of the Taxes (in $) of Sweden in 2006 to that in 2008?
Provide a succinct answer. 1.51. What is the ratio of the Taxes (in $) in Botswana in 2006 to that in 2009?
Ensure brevity in your answer.  0.87. What is the ratio of the Taxes (in $) of Guatemala in 2006 to that in 2009?
Offer a very short reply. 0.79. What is the ratio of the Taxes (in $) of Jordan in 2006 to that in 2009?
Keep it short and to the point. 0.54. What is the ratio of the Taxes (in $) of Sweden in 2006 to that in 2009?
Keep it short and to the point. 1.87. What is the ratio of the Taxes (in $) in Botswana in 2006 to that in 2010?
Give a very brief answer. 0.73. What is the ratio of the Taxes (in $) of Guatemala in 2006 to that in 2010?
Your answer should be very brief. 0.74. What is the ratio of the Taxes (in $) in Jordan in 2006 to that in 2010?
Provide a succinct answer. 0.66. What is the ratio of the Taxes (in $) of Sweden in 2006 to that in 2010?
Your response must be concise. 1.53. What is the ratio of the Taxes (in $) in Botswana in 2007 to that in 2008?
Offer a terse response. 0.79. What is the ratio of the Taxes (in $) of Guatemala in 2007 to that in 2008?
Give a very brief answer. 0.89. What is the ratio of the Taxes (in $) in Jordan in 2007 to that in 2008?
Provide a succinct answer. 0.82. What is the ratio of the Taxes (in $) of Sweden in 2007 to that in 2008?
Your answer should be very brief. 1.43. What is the ratio of the Taxes (in $) in Botswana in 2007 to that in 2009?
Your answer should be compact. 0.8. What is the ratio of the Taxes (in $) in Guatemala in 2007 to that in 2009?
Keep it short and to the point. 0.89. What is the ratio of the Taxes (in $) of Jordan in 2007 to that in 2009?
Your answer should be compact. 0.65. What is the ratio of the Taxes (in $) of Sweden in 2007 to that in 2009?
Your response must be concise. 1.77. What is the ratio of the Taxes (in $) in Botswana in 2007 to that in 2010?
Keep it short and to the point. 0.68. What is the ratio of the Taxes (in $) in Guatemala in 2007 to that in 2010?
Provide a short and direct response. 0.84. What is the ratio of the Taxes (in $) of Jordan in 2007 to that in 2010?
Your answer should be compact. 0.79. What is the ratio of the Taxes (in $) of Sweden in 2007 to that in 2010?
Make the answer very short. 1.45. What is the ratio of the Taxes (in $) of Botswana in 2008 to that in 2009?
Keep it short and to the point. 1.02. What is the ratio of the Taxes (in $) in Jordan in 2008 to that in 2009?
Provide a short and direct response. 0.79. What is the ratio of the Taxes (in $) of Sweden in 2008 to that in 2009?
Make the answer very short. 1.24. What is the ratio of the Taxes (in $) in Botswana in 2008 to that in 2010?
Your answer should be compact. 0.86. What is the ratio of the Taxes (in $) of Guatemala in 2008 to that in 2010?
Your answer should be compact. 0.94. What is the ratio of the Taxes (in $) of Jordan in 2008 to that in 2010?
Keep it short and to the point. 0.97. What is the ratio of the Taxes (in $) of Botswana in 2009 to that in 2010?
Your answer should be very brief. 0.85. What is the ratio of the Taxes (in $) in Guatemala in 2009 to that in 2010?
Give a very brief answer. 0.94. What is the ratio of the Taxes (in $) in Jordan in 2009 to that in 2010?
Offer a terse response. 1.22. What is the ratio of the Taxes (in $) of Sweden in 2009 to that in 2010?
Provide a succinct answer. 0.82. What is the difference between the highest and the second highest Taxes (in $) in Botswana?
Your response must be concise. 1.30e+09. What is the difference between the highest and the second highest Taxes (in $) in Guatemala?
Give a very brief answer. 6.13e+08. What is the difference between the highest and the second highest Taxes (in $) in Jordan?
Ensure brevity in your answer.  1.40e+08. What is the difference between the highest and the second highest Taxes (in $) of Sweden?
Offer a terse response. 9.30e+09. What is the difference between the highest and the lowest Taxes (in $) in Botswana?
Your answer should be very brief. 8.24e+09. What is the difference between the highest and the lowest Taxes (in $) in Guatemala?
Provide a short and direct response. 8.95e+09. What is the difference between the highest and the lowest Taxes (in $) in Jordan?
Provide a short and direct response. 6.12e+08. What is the difference between the highest and the lowest Taxes (in $) of Sweden?
Provide a short and direct response. 9.76e+1. 